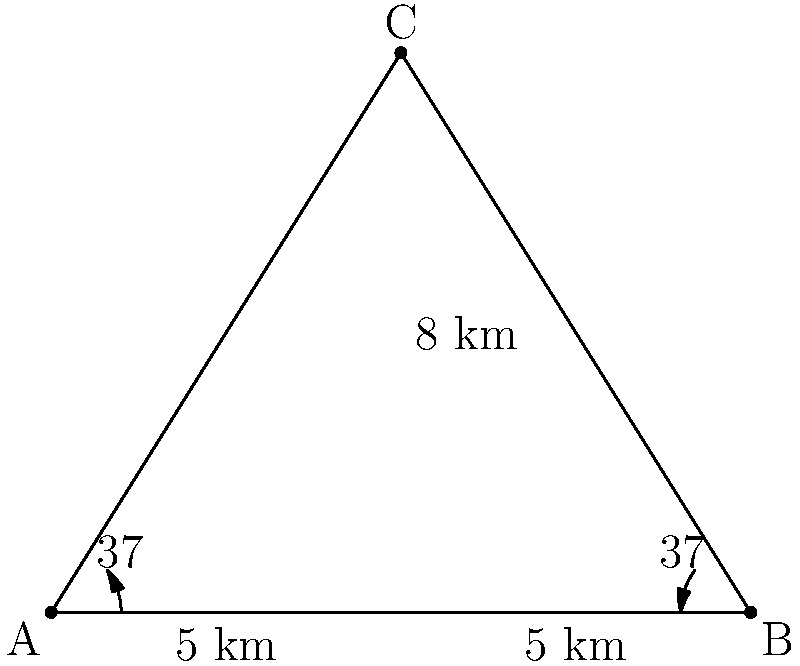Two radio direction-finding stations, A and B, are positioned 10 km apart along a straight baseline. They detect a signal from an unknown transmitter C. Station A measures an angle of 37° to the right of the baseline, while station B measures an angle of 37° to the left of the baseline. Calculate the distance from station A to the transmitter C. Let's approach this step-by-step using trigonometry:

1) First, we recognize that this forms an isosceles triangle. The two base angles are equal (both 37°), which means the two sides AC and BC are equal in length.

2) We can split this isosceles triangle into two right-angled triangles by drawing a perpendicular line from C to the baseline AB. This line will bisect AB, giving us two 5 km segments.

3) Now we have a right-angled triangle with the following properties:
   - The hypotenuse is the distance we're looking for (AC)
   - We know the base is 5 km
   - We know the angle is 37°

4) In this right-angled triangle, we can use the tangent function:

   $$\tan 37° = \frac{\text{opposite}}{\text{adjacent}} = \frac{h}{5}$$

   Where h is the height of the triangle.

5) We can rearrange this to find h:

   $$h = 5 \tan 37° \approx 3.75 \text{ km}$$

6) Now we have a right-angled triangle where we know both the base (5 km) and the height (3.75 km). We can use the Pythagorean theorem to find the hypotenuse (which is the distance from A to C):

   $$AC^2 = 5^2 + 3.75^2$$

7) Solving this:

   $$AC = \sqrt{5^2 + 3.75^2} \approx 6.25 \text{ km}$$

Therefore, the distance from station A to the transmitter C is approximately 6.25 km.
Answer: 6.25 km 